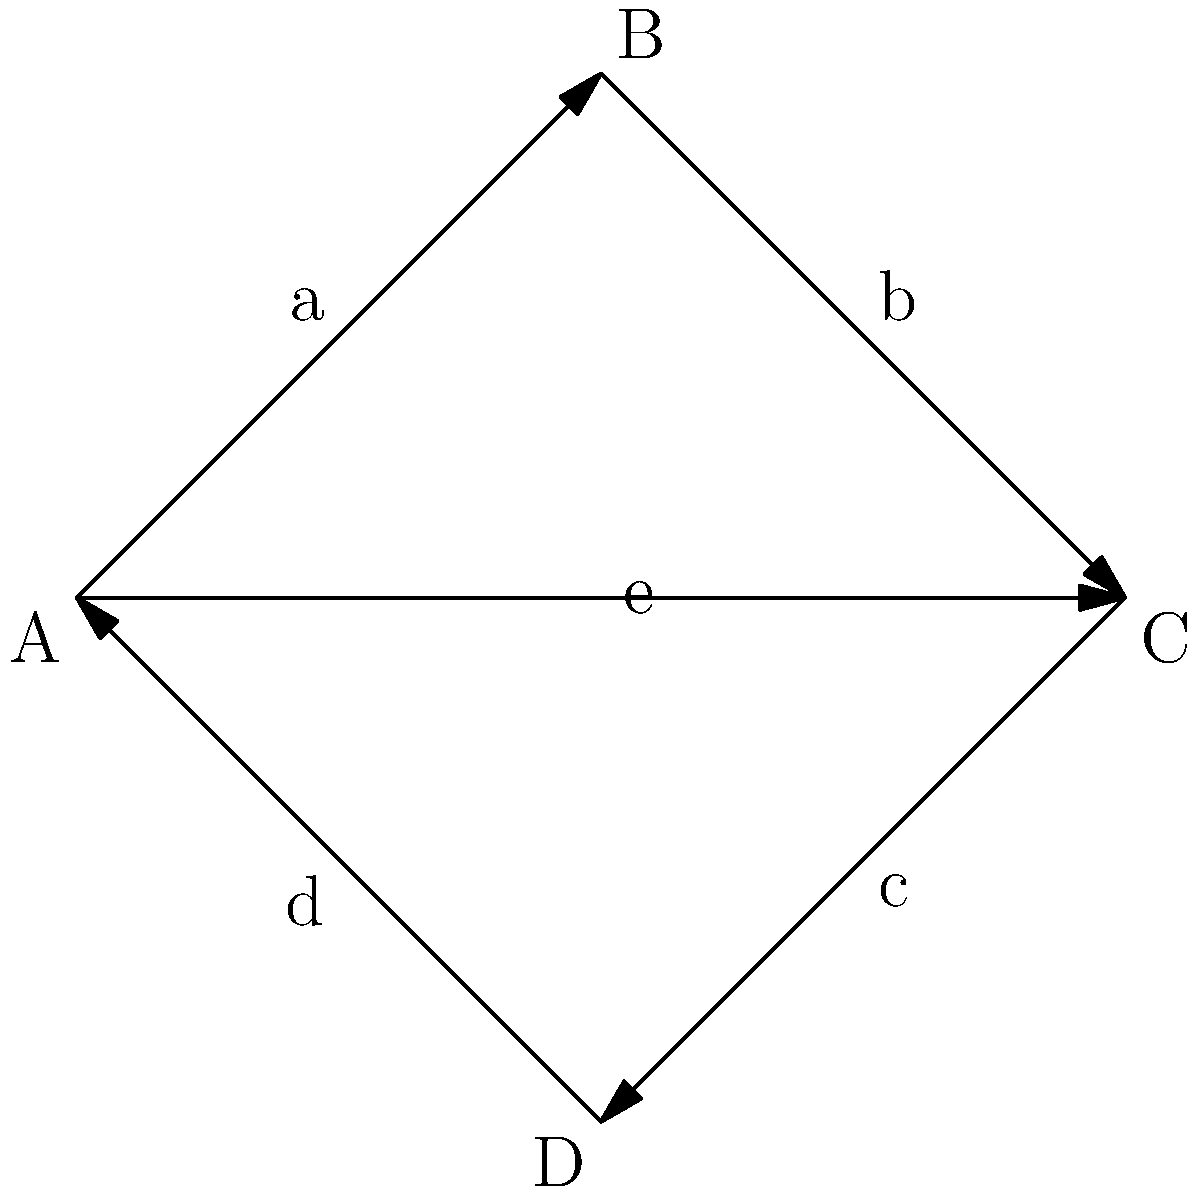In the Cayley graph representing different rehabilitation program paths for offenders, what is the total number of distinct paths from program A to program C that do not revisit any program? To solve this problem, we need to follow these steps:

1. Identify the starting point (A) and ending point (C) in the Cayley graph.

2. List all possible paths from A to C without revisiting any program:
   - Path 1: A → B → C
   - Path 2: A → C (direct path)
   - Path 3: A → D → C

3. Count the number of distinct paths:
   There are 3 distinct paths from A to C.

4. Verify that each path meets the criteria:
   - None of the paths revisit any program.
   - All paths start at A and end at C.
   - Each path represents a unique sequence of rehabilitation programs.

5. The total number of distinct paths from A to C without revisiting any program is 3.

This analysis demonstrates the different rehabilitation program paths available to offenders, highlighting the importance of multiple approaches in crime rehabilitation strategies.
Answer: 3 